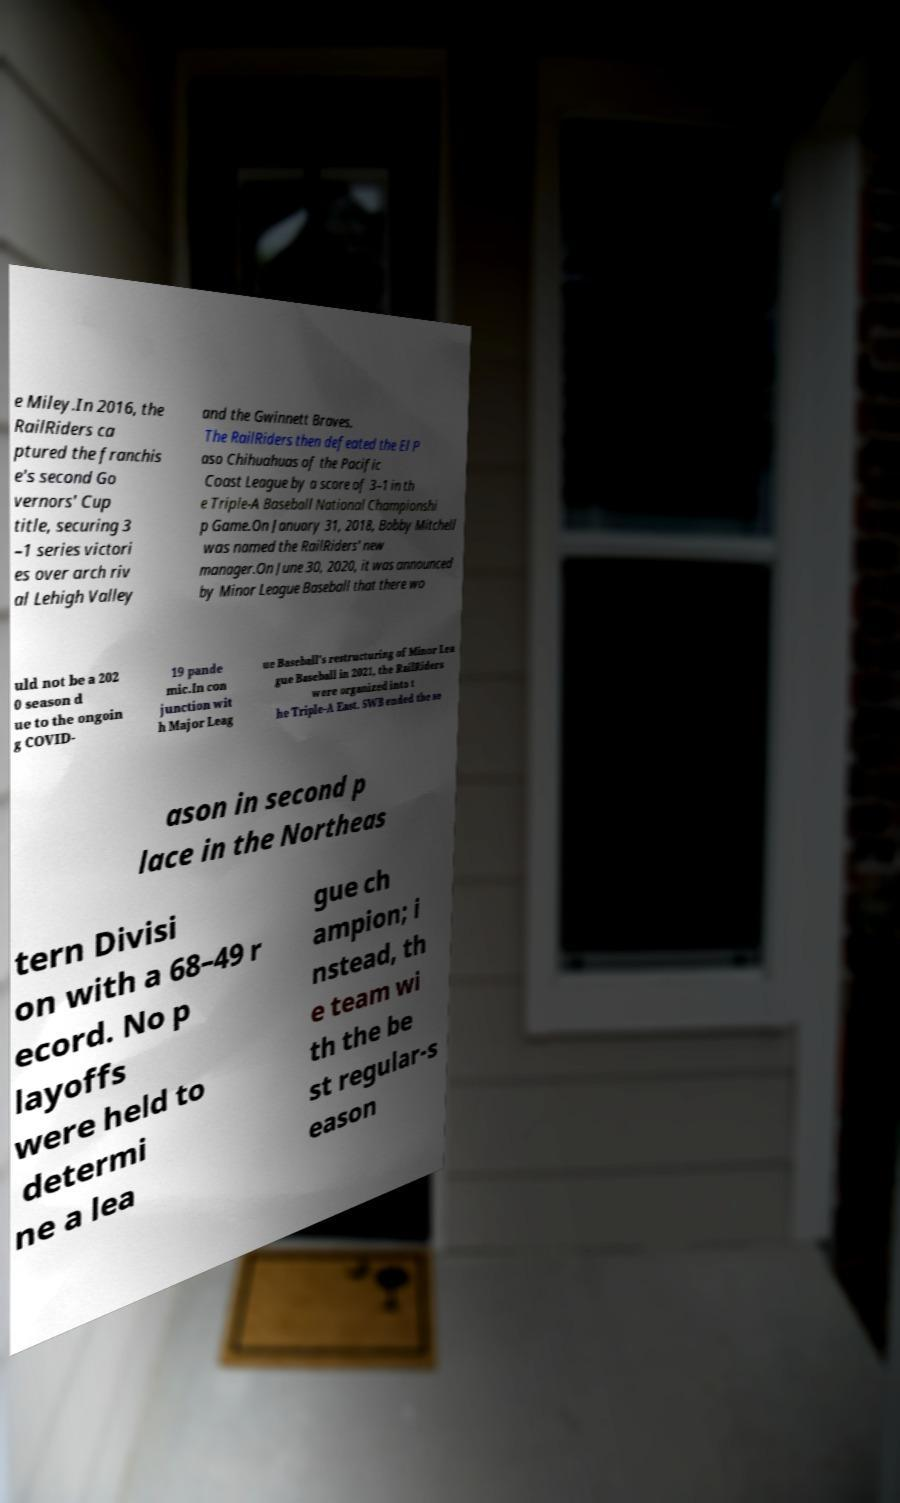Can you read and provide the text displayed in the image?This photo seems to have some interesting text. Can you extract and type it out for me? e Miley.In 2016, the RailRiders ca ptured the franchis e's second Go vernors' Cup title, securing 3 –1 series victori es over arch riv al Lehigh Valley and the Gwinnett Braves. The RailRiders then defeated the El P aso Chihuahuas of the Pacific Coast League by a score of 3–1 in th e Triple-A Baseball National Championshi p Game.On January 31, 2018, Bobby Mitchell was named the RailRiders' new manager.On June 30, 2020, it was announced by Minor League Baseball that there wo uld not be a 202 0 season d ue to the ongoin g COVID- 19 pande mic.In con junction wit h Major Leag ue Baseball's restructuring of Minor Lea gue Baseball in 2021, the RailRiders were organized into t he Triple-A East. SWB ended the se ason in second p lace in the Northeas tern Divisi on with a 68–49 r ecord. No p layoffs were held to determi ne a lea gue ch ampion; i nstead, th e team wi th the be st regular-s eason 